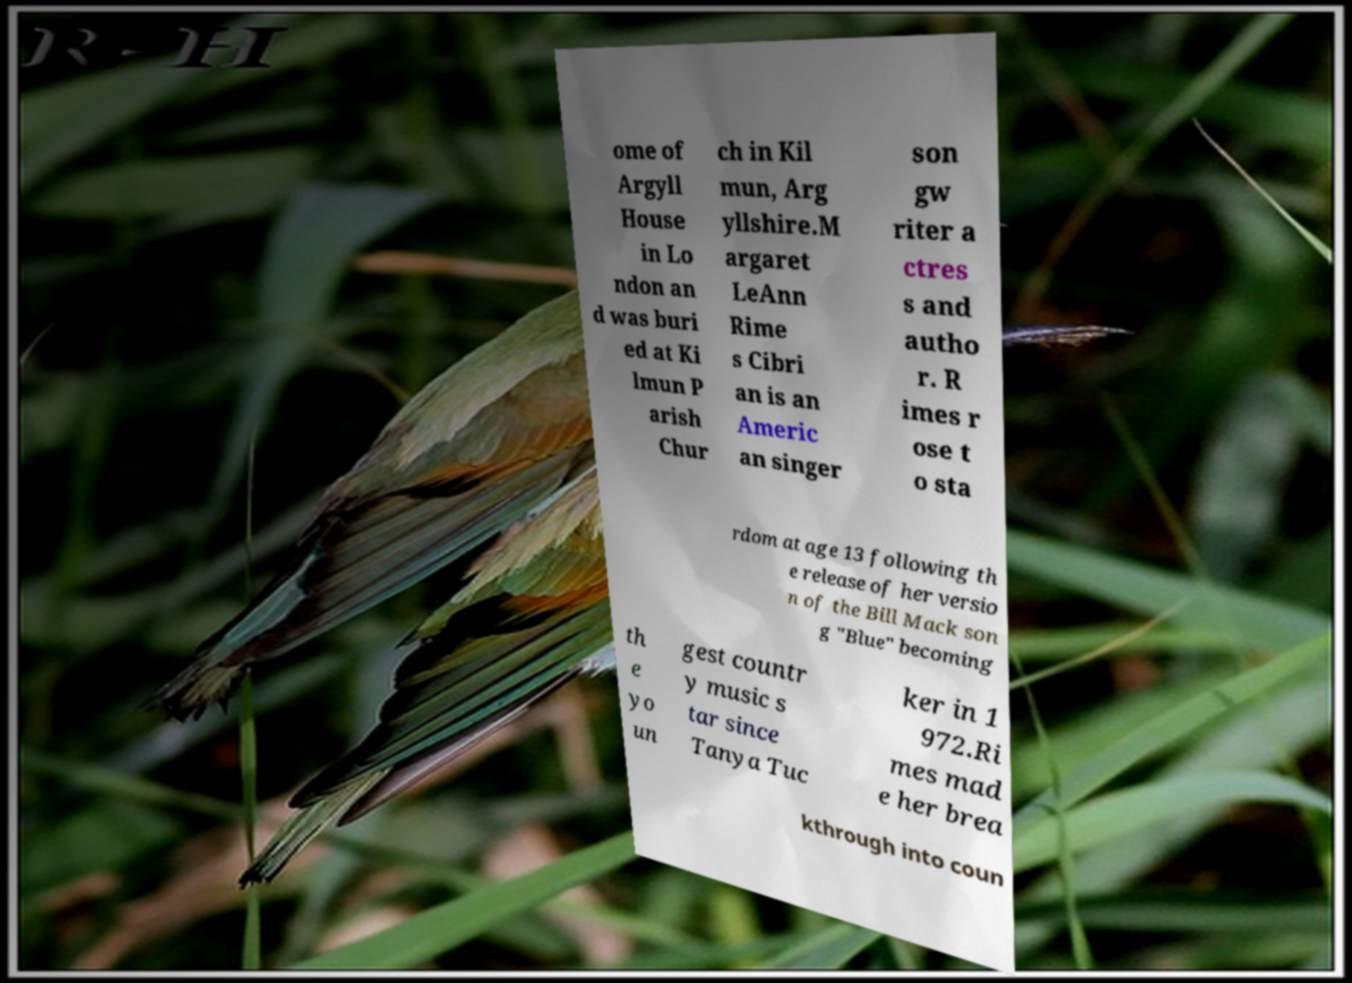Can you accurately transcribe the text from the provided image for me? ome of Argyll House in Lo ndon an d was buri ed at Ki lmun P arish Chur ch in Kil mun, Arg yllshire.M argaret LeAnn Rime s Cibri an is an Americ an singer son gw riter a ctres s and autho r. R imes r ose t o sta rdom at age 13 following th e release of her versio n of the Bill Mack son g "Blue" becoming th e yo un gest countr y music s tar since Tanya Tuc ker in 1 972.Ri mes mad e her brea kthrough into coun 